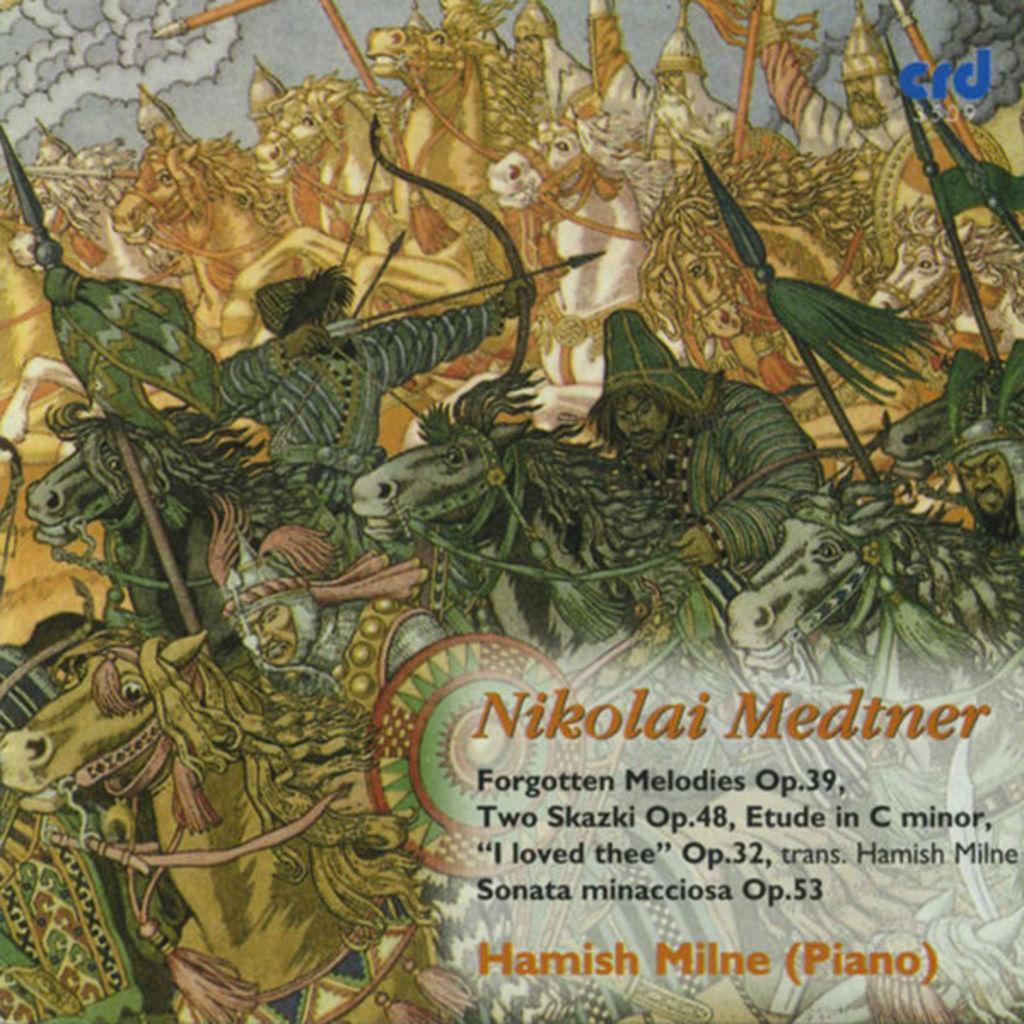How would you summarize this image in a sentence or two? This image is a picture. In this image we can see persons, horses, bows and arrows. At the bottom right corner there is a text. 